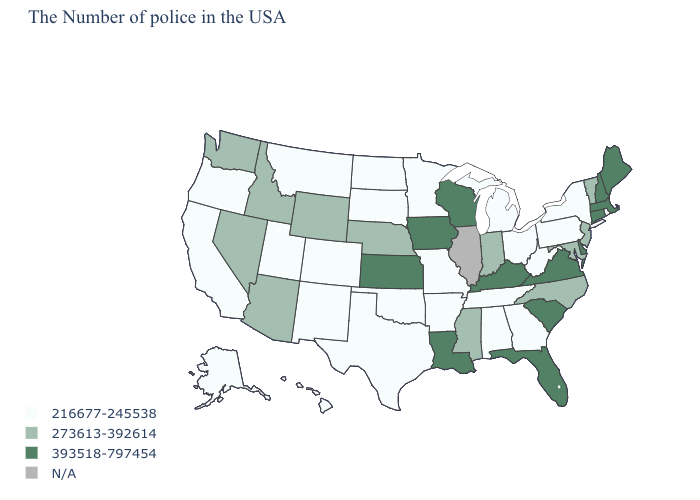Is the legend a continuous bar?
Quick response, please. No. What is the lowest value in the Northeast?
Be succinct. 216677-245538. Name the states that have a value in the range 216677-245538?
Keep it brief. Rhode Island, New York, Pennsylvania, West Virginia, Ohio, Georgia, Michigan, Alabama, Tennessee, Missouri, Arkansas, Minnesota, Oklahoma, Texas, South Dakota, North Dakota, Colorado, New Mexico, Utah, Montana, California, Oregon, Alaska, Hawaii. Which states have the lowest value in the Northeast?
Keep it brief. Rhode Island, New York, Pennsylvania. What is the value of Oklahoma?
Concise answer only. 216677-245538. Does Virginia have the highest value in the South?
Keep it brief. Yes. Name the states that have a value in the range N/A?
Concise answer only. Illinois. Among the states that border Maryland , which have the lowest value?
Keep it brief. Pennsylvania, West Virginia. Does South Dakota have the highest value in the USA?
Give a very brief answer. No. Name the states that have a value in the range 273613-392614?
Be succinct. Vermont, New Jersey, Maryland, North Carolina, Indiana, Mississippi, Nebraska, Wyoming, Arizona, Idaho, Nevada, Washington. What is the value of Pennsylvania?
Answer briefly. 216677-245538. What is the lowest value in the Northeast?
Short answer required. 216677-245538. Does Oklahoma have the highest value in the South?
Give a very brief answer. No. 